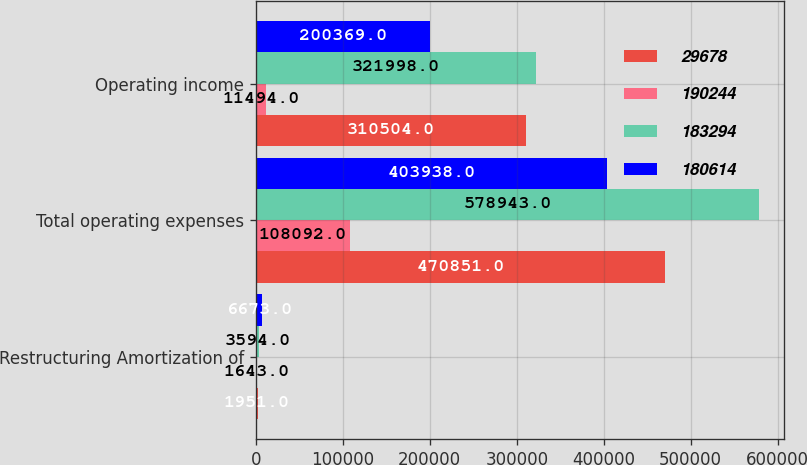Convert chart. <chart><loc_0><loc_0><loc_500><loc_500><stacked_bar_chart><ecel><fcel>Restructuring Amortization of<fcel>Total operating expenses<fcel>Operating income<nl><fcel>29678<fcel>1951<fcel>470851<fcel>310504<nl><fcel>190244<fcel>1643<fcel>108092<fcel>11494<nl><fcel>183294<fcel>3594<fcel>578943<fcel>321998<nl><fcel>180614<fcel>6673<fcel>403938<fcel>200369<nl></chart> 